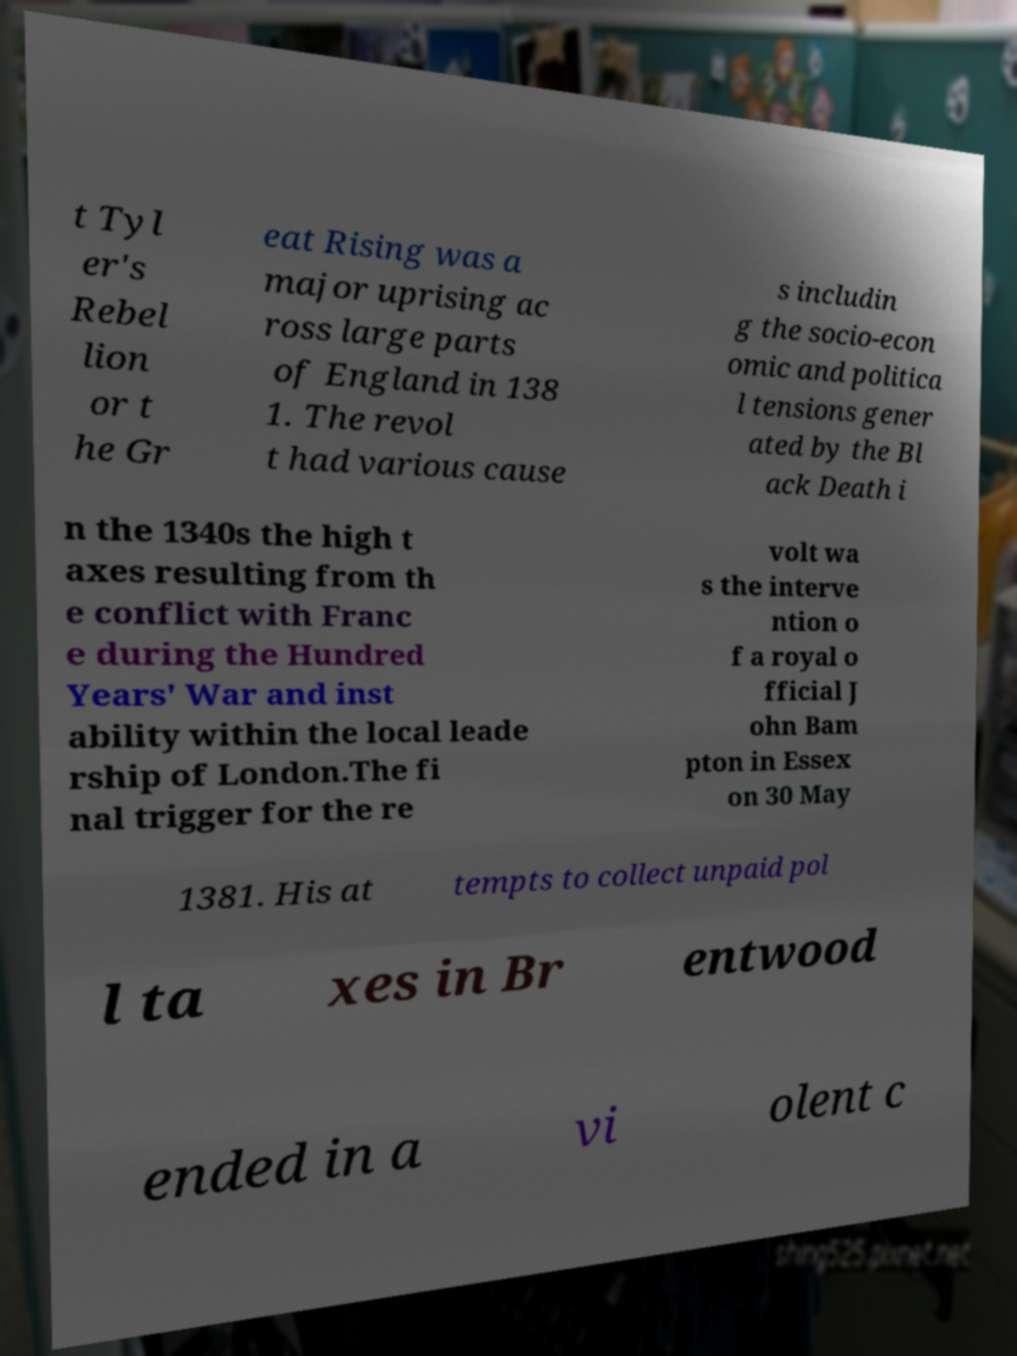For documentation purposes, I need the text within this image transcribed. Could you provide that? t Tyl er's Rebel lion or t he Gr eat Rising was a major uprising ac ross large parts of England in 138 1. The revol t had various cause s includin g the socio-econ omic and politica l tensions gener ated by the Bl ack Death i n the 1340s the high t axes resulting from th e conflict with Franc e during the Hundred Years' War and inst ability within the local leade rship of London.The fi nal trigger for the re volt wa s the interve ntion o f a royal o fficial J ohn Bam pton in Essex on 30 May 1381. His at tempts to collect unpaid pol l ta xes in Br entwood ended in a vi olent c 